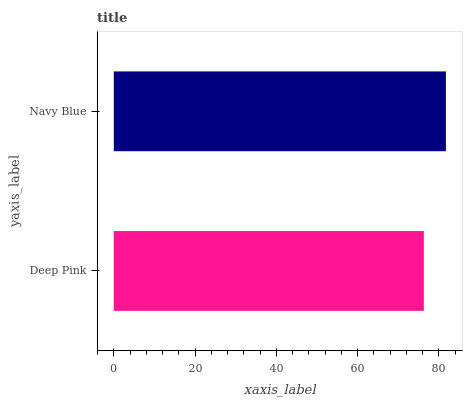Is Deep Pink the minimum?
Answer yes or no. Yes. Is Navy Blue the maximum?
Answer yes or no. Yes. Is Navy Blue the minimum?
Answer yes or no. No. Is Navy Blue greater than Deep Pink?
Answer yes or no. Yes. Is Deep Pink less than Navy Blue?
Answer yes or no. Yes. Is Deep Pink greater than Navy Blue?
Answer yes or no. No. Is Navy Blue less than Deep Pink?
Answer yes or no. No. Is Navy Blue the high median?
Answer yes or no. Yes. Is Deep Pink the low median?
Answer yes or no. Yes. Is Deep Pink the high median?
Answer yes or no. No. Is Navy Blue the low median?
Answer yes or no. No. 